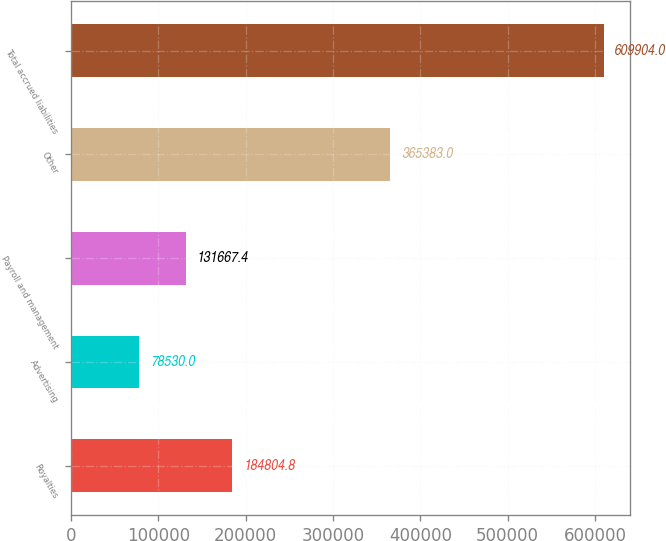Convert chart. <chart><loc_0><loc_0><loc_500><loc_500><bar_chart><fcel>Royalties<fcel>Advertising<fcel>Payroll and management<fcel>Other<fcel>Total accrued liabilities<nl><fcel>184805<fcel>78530<fcel>131667<fcel>365383<fcel>609904<nl></chart> 